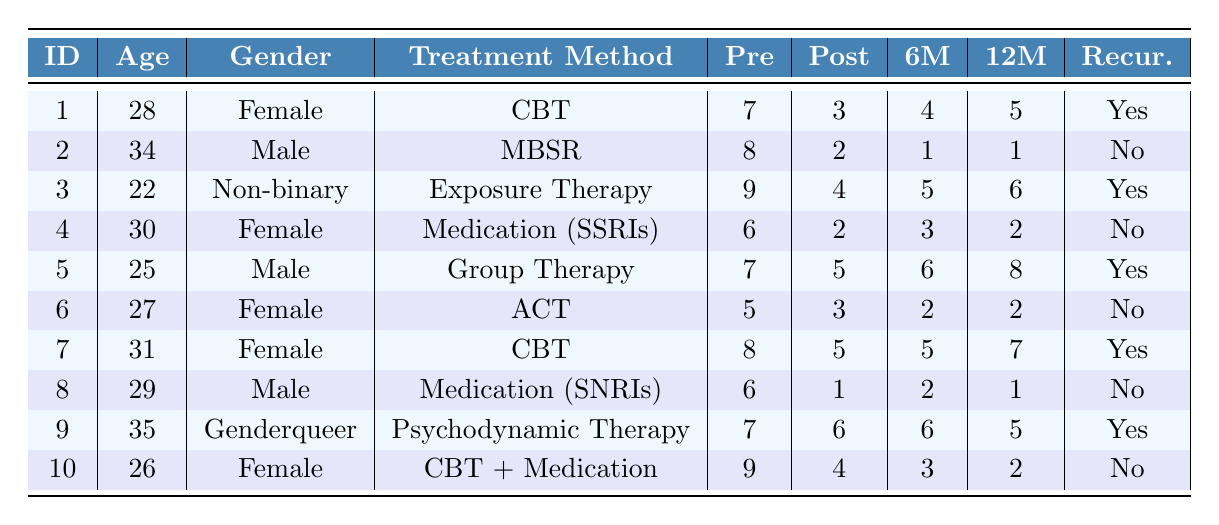What is the treatment method used by ParticipantID 5? By looking at the row corresponding to ParticipantID 5 in the table, we can see that the treatment method listed is Group Therapy.
Answer: Group Therapy How many participants experienced recurrence of social anxiety symptoms? In the table, we can identify participants who had "Yes" in the Recurrence column. There are 5 such instances (ParticipantID 1, 3, 5, 7, and 9).
Answer: 5 What was the highest number of symptoms reported before treatment? By scanning the SymptomsPreTreatment column, we find the highest value is 9, reported by Participants 3 and 10.
Answer: 9 What is the average number of symptoms at the 12-month follow-up for participants who did not experience recurrence? We first identify participants with Recurrence marked as "No" and their 12-month follow-up symptoms: 2, 1, 2. Summing these gives 2 + 1 + 2 = 5. There are 3 such participants, so the average is 5/3 = 1.67.
Answer: 1.67 Did ParticipantID 4 experience recurrence of symptoms? According to the Recurrence column for ParticipantID 4, it states "No," indicating they did not have a recurrence.
Answer: No Which treatment method had both the highest pre-treatment symptoms and resulted in recurrence? We look at the Participants with recurrence. Participant 3 had the highest pre-treatment symptoms score of 9, using Exposure Therapy.
Answer: Exposure Therapy What is the difference in the number of symptoms reported immediately post-treatment between Participants 1 and 3? Participant 1 had 3 symptoms post-treatment, while Participant 3 had 4. The difference is calculated as 4 - 3 = 1.
Answer: 1 What percentage of participants were male in this study? There are 10 total participants, and 4 of them are male (ParticipantID 2, 5, 8). The percentage is calculated as (4/10) * 100 = 40%.
Answer: 40% At the 6-month follow-up, which treatment method had the lowest average symptoms? We need to calculate the average symptoms at the 6-month follow-up for all treatment methods. The averages are: CBT (5), MBSR (1), Exposure Therapy (5), SSRIs (3), Group Therapy (6), ACT (2), SNRIs (2), Psychodynamic (6), CBT + Medication (3). MBSR has the lowest at 1.
Answer: MBSR How many participants were treated with Cognitive Behavioral Therapy? By counting the instances of "Cognitive Behavioral Therapy (CBT)" in the Treatment Method column, we find there were 3 participants who received CBT.
Answer: 3 